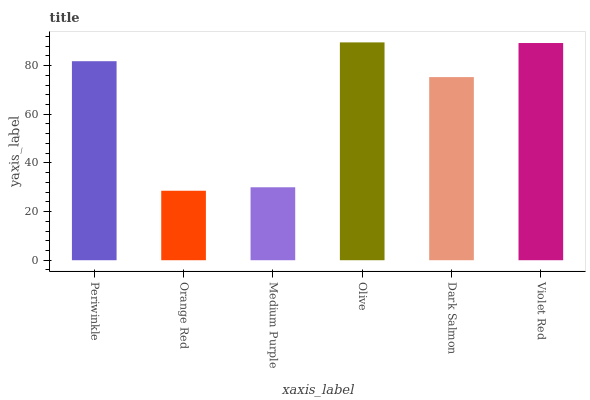Is Orange Red the minimum?
Answer yes or no. Yes. Is Olive the maximum?
Answer yes or no. Yes. Is Medium Purple the minimum?
Answer yes or no. No. Is Medium Purple the maximum?
Answer yes or no. No. Is Medium Purple greater than Orange Red?
Answer yes or no. Yes. Is Orange Red less than Medium Purple?
Answer yes or no. Yes. Is Orange Red greater than Medium Purple?
Answer yes or no. No. Is Medium Purple less than Orange Red?
Answer yes or no. No. Is Periwinkle the high median?
Answer yes or no. Yes. Is Dark Salmon the low median?
Answer yes or no. Yes. Is Orange Red the high median?
Answer yes or no. No. Is Orange Red the low median?
Answer yes or no. No. 